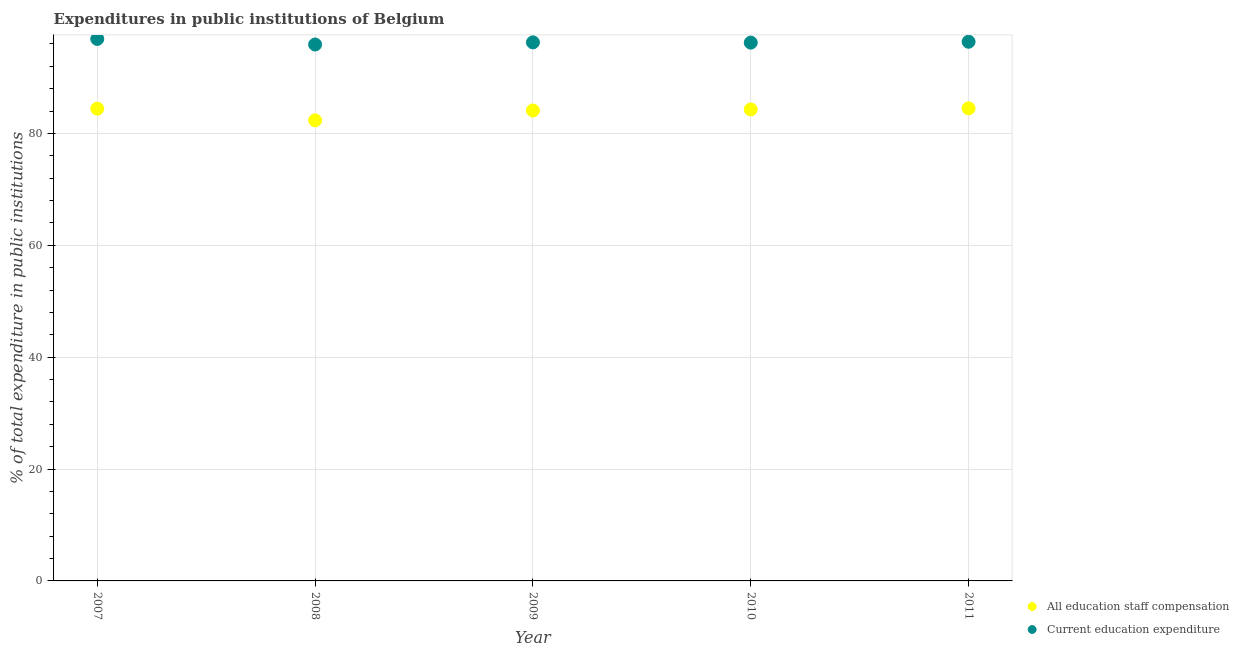How many different coloured dotlines are there?
Your answer should be very brief. 2. What is the expenditure in staff compensation in 2009?
Make the answer very short. 84.1. Across all years, what is the maximum expenditure in staff compensation?
Provide a short and direct response. 84.48. Across all years, what is the minimum expenditure in staff compensation?
Your answer should be very brief. 82.33. In which year was the expenditure in education maximum?
Make the answer very short. 2007. In which year was the expenditure in education minimum?
Offer a very short reply. 2008. What is the total expenditure in staff compensation in the graph?
Make the answer very short. 419.61. What is the difference between the expenditure in staff compensation in 2007 and that in 2009?
Your answer should be compact. 0.32. What is the difference between the expenditure in education in 2011 and the expenditure in staff compensation in 2009?
Give a very brief answer. 12.28. What is the average expenditure in education per year?
Your answer should be compact. 96.33. In the year 2011, what is the difference between the expenditure in staff compensation and expenditure in education?
Your answer should be compact. -11.9. In how many years, is the expenditure in staff compensation greater than 48 %?
Your answer should be very brief. 5. What is the ratio of the expenditure in staff compensation in 2008 to that in 2011?
Provide a short and direct response. 0.97. What is the difference between the highest and the second highest expenditure in staff compensation?
Offer a terse response. 0.07. What is the difference between the highest and the lowest expenditure in education?
Your response must be concise. 0.99. Is the expenditure in education strictly greater than the expenditure in staff compensation over the years?
Your answer should be very brief. Yes. How many years are there in the graph?
Provide a short and direct response. 5. What is the difference between two consecutive major ticks on the Y-axis?
Your answer should be compact. 20. Are the values on the major ticks of Y-axis written in scientific E-notation?
Give a very brief answer. No. Does the graph contain grids?
Offer a terse response. Yes. Where does the legend appear in the graph?
Ensure brevity in your answer.  Bottom right. How are the legend labels stacked?
Keep it short and to the point. Vertical. What is the title of the graph?
Your answer should be compact. Expenditures in public institutions of Belgium. Does "Foreign liabilities" appear as one of the legend labels in the graph?
Your answer should be very brief. No. What is the label or title of the X-axis?
Provide a short and direct response. Year. What is the label or title of the Y-axis?
Your answer should be very brief. % of total expenditure in public institutions. What is the % of total expenditure in public institutions in All education staff compensation in 2007?
Your answer should be compact. 84.42. What is the % of total expenditure in public institutions of Current education expenditure in 2007?
Provide a succinct answer. 96.88. What is the % of total expenditure in public institutions in All education staff compensation in 2008?
Your answer should be compact. 82.33. What is the % of total expenditure in public institutions of Current education expenditure in 2008?
Your answer should be compact. 95.89. What is the % of total expenditure in public institutions of All education staff compensation in 2009?
Your answer should be very brief. 84.1. What is the % of total expenditure in public institutions of Current education expenditure in 2009?
Keep it short and to the point. 96.27. What is the % of total expenditure in public institutions of All education staff compensation in 2010?
Make the answer very short. 84.28. What is the % of total expenditure in public institutions of Current education expenditure in 2010?
Your answer should be very brief. 96.22. What is the % of total expenditure in public institutions in All education staff compensation in 2011?
Offer a terse response. 84.48. What is the % of total expenditure in public institutions in Current education expenditure in 2011?
Make the answer very short. 96.38. Across all years, what is the maximum % of total expenditure in public institutions of All education staff compensation?
Keep it short and to the point. 84.48. Across all years, what is the maximum % of total expenditure in public institutions in Current education expenditure?
Offer a very short reply. 96.88. Across all years, what is the minimum % of total expenditure in public institutions of All education staff compensation?
Offer a very short reply. 82.33. Across all years, what is the minimum % of total expenditure in public institutions of Current education expenditure?
Provide a short and direct response. 95.89. What is the total % of total expenditure in public institutions in All education staff compensation in the graph?
Provide a short and direct response. 419.61. What is the total % of total expenditure in public institutions of Current education expenditure in the graph?
Give a very brief answer. 481.64. What is the difference between the % of total expenditure in public institutions of All education staff compensation in 2007 and that in 2008?
Give a very brief answer. 2.09. What is the difference between the % of total expenditure in public institutions in All education staff compensation in 2007 and that in 2009?
Provide a short and direct response. 0.32. What is the difference between the % of total expenditure in public institutions of Current education expenditure in 2007 and that in 2009?
Your response must be concise. 0.61. What is the difference between the % of total expenditure in public institutions of All education staff compensation in 2007 and that in 2010?
Make the answer very short. 0.14. What is the difference between the % of total expenditure in public institutions of Current education expenditure in 2007 and that in 2010?
Ensure brevity in your answer.  0.66. What is the difference between the % of total expenditure in public institutions of All education staff compensation in 2007 and that in 2011?
Your answer should be very brief. -0.07. What is the difference between the % of total expenditure in public institutions of Current education expenditure in 2007 and that in 2011?
Give a very brief answer. 0.5. What is the difference between the % of total expenditure in public institutions of All education staff compensation in 2008 and that in 2009?
Offer a very short reply. -1.77. What is the difference between the % of total expenditure in public institutions in Current education expenditure in 2008 and that in 2009?
Give a very brief answer. -0.38. What is the difference between the % of total expenditure in public institutions of All education staff compensation in 2008 and that in 2010?
Make the answer very short. -1.96. What is the difference between the % of total expenditure in public institutions of Current education expenditure in 2008 and that in 2010?
Provide a short and direct response. -0.33. What is the difference between the % of total expenditure in public institutions of All education staff compensation in 2008 and that in 2011?
Ensure brevity in your answer.  -2.16. What is the difference between the % of total expenditure in public institutions of Current education expenditure in 2008 and that in 2011?
Offer a terse response. -0.49. What is the difference between the % of total expenditure in public institutions in All education staff compensation in 2009 and that in 2010?
Your response must be concise. -0.19. What is the difference between the % of total expenditure in public institutions in Current education expenditure in 2009 and that in 2010?
Your answer should be very brief. 0.04. What is the difference between the % of total expenditure in public institutions in All education staff compensation in 2009 and that in 2011?
Offer a terse response. -0.39. What is the difference between the % of total expenditure in public institutions in Current education expenditure in 2009 and that in 2011?
Offer a very short reply. -0.11. What is the difference between the % of total expenditure in public institutions in All education staff compensation in 2010 and that in 2011?
Offer a very short reply. -0.2. What is the difference between the % of total expenditure in public institutions of Current education expenditure in 2010 and that in 2011?
Your answer should be compact. -0.16. What is the difference between the % of total expenditure in public institutions of All education staff compensation in 2007 and the % of total expenditure in public institutions of Current education expenditure in 2008?
Make the answer very short. -11.47. What is the difference between the % of total expenditure in public institutions in All education staff compensation in 2007 and the % of total expenditure in public institutions in Current education expenditure in 2009?
Your response must be concise. -11.85. What is the difference between the % of total expenditure in public institutions of All education staff compensation in 2007 and the % of total expenditure in public institutions of Current education expenditure in 2010?
Give a very brief answer. -11.8. What is the difference between the % of total expenditure in public institutions of All education staff compensation in 2007 and the % of total expenditure in public institutions of Current education expenditure in 2011?
Your response must be concise. -11.96. What is the difference between the % of total expenditure in public institutions in All education staff compensation in 2008 and the % of total expenditure in public institutions in Current education expenditure in 2009?
Provide a short and direct response. -13.94. What is the difference between the % of total expenditure in public institutions of All education staff compensation in 2008 and the % of total expenditure in public institutions of Current education expenditure in 2010?
Provide a succinct answer. -13.9. What is the difference between the % of total expenditure in public institutions in All education staff compensation in 2008 and the % of total expenditure in public institutions in Current education expenditure in 2011?
Make the answer very short. -14.05. What is the difference between the % of total expenditure in public institutions of All education staff compensation in 2009 and the % of total expenditure in public institutions of Current education expenditure in 2010?
Your response must be concise. -12.13. What is the difference between the % of total expenditure in public institutions in All education staff compensation in 2009 and the % of total expenditure in public institutions in Current education expenditure in 2011?
Your response must be concise. -12.28. What is the difference between the % of total expenditure in public institutions of All education staff compensation in 2010 and the % of total expenditure in public institutions of Current education expenditure in 2011?
Give a very brief answer. -12.1. What is the average % of total expenditure in public institutions in All education staff compensation per year?
Provide a succinct answer. 83.92. What is the average % of total expenditure in public institutions of Current education expenditure per year?
Make the answer very short. 96.33. In the year 2007, what is the difference between the % of total expenditure in public institutions in All education staff compensation and % of total expenditure in public institutions in Current education expenditure?
Your response must be concise. -12.46. In the year 2008, what is the difference between the % of total expenditure in public institutions of All education staff compensation and % of total expenditure in public institutions of Current education expenditure?
Keep it short and to the point. -13.56. In the year 2009, what is the difference between the % of total expenditure in public institutions of All education staff compensation and % of total expenditure in public institutions of Current education expenditure?
Your answer should be compact. -12.17. In the year 2010, what is the difference between the % of total expenditure in public institutions of All education staff compensation and % of total expenditure in public institutions of Current education expenditure?
Your answer should be compact. -11.94. In the year 2011, what is the difference between the % of total expenditure in public institutions in All education staff compensation and % of total expenditure in public institutions in Current education expenditure?
Make the answer very short. -11.9. What is the ratio of the % of total expenditure in public institutions in All education staff compensation in 2007 to that in 2008?
Your response must be concise. 1.03. What is the ratio of the % of total expenditure in public institutions in Current education expenditure in 2007 to that in 2008?
Make the answer very short. 1.01. What is the ratio of the % of total expenditure in public institutions in All education staff compensation in 2007 to that in 2009?
Give a very brief answer. 1. What is the ratio of the % of total expenditure in public institutions in Current education expenditure in 2007 to that in 2009?
Your answer should be compact. 1.01. What is the ratio of the % of total expenditure in public institutions in All education staff compensation in 2007 to that in 2011?
Your answer should be very brief. 1. What is the ratio of the % of total expenditure in public institutions of Current education expenditure in 2007 to that in 2011?
Make the answer very short. 1.01. What is the ratio of the % of total expenditure in public institutions of All education staff compensation in 2008 to that in 2009?
Make the answer very short. 0.98. What is the ratio of the % of total expenditure in public institutions in All education staff compensation in 2008 to that in 2010?
Your answer should be very brief. 0.98. What is the ratio of the % of total expenditure in public institutions in All education staff compensation in 2008 to that in 2011?
Provide a short and direct response. 0.97. What is the ratio of the % of total expenditure in public institutions in Current education expenditure in 2008 to that in 2011?
Offer a terse response. 0.99. What is the ratio of the % of total expenditure in public institutions in Current education expenditure in 2009 to that in 2010?
Provide a short and direct response. 1. What is the ratio of the % of total expenditure in public institutions of All education staff compensation in 2009 to that in 2011?
Offer a very short reply. 1. What is the ratio of the % of total expenditure in public institutions in Current education expenditure in 2009 to that in 2011?
Your response must be concise. 1. What is the ratio of the % of total expenditure in public institutions of All education staff compensation in 2010 to that in 2011?
Ensure brevity in your answer.  1. What is the difference between the highest and the second highest % of total expenditure in public institutions of All education staff compensation?
Keep it short and to the point. 0.07. What is the difference between the highest and the second highest % of total expenditure in public institutions in Current education expenditure?
Your answer should be very brief. 0.5. What is the difference between the highest and the lowest % of total expenditure in public institutions of All education staff compensation?
Provide a succinct answer. 2.16. What is the difference between the highest and the lowest % of total expenditure in public institutions of Current education expenditure?
Make the answer very short. 0.99. 